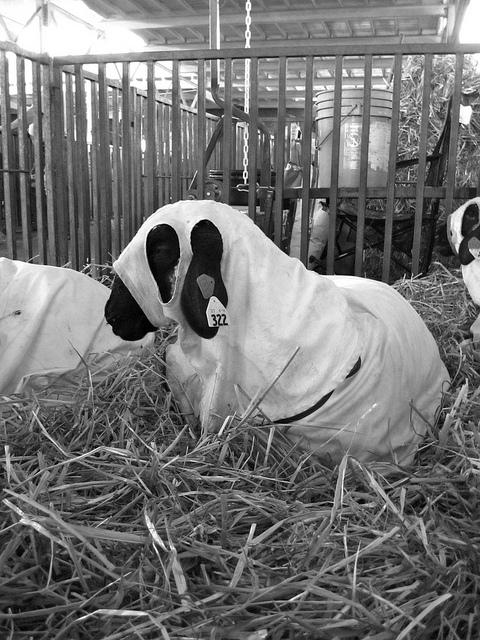The first digit of the number that is clipped to the ear is included in what number? Please explain your reasoning. 305. This is the only number with the number 3 in it. 